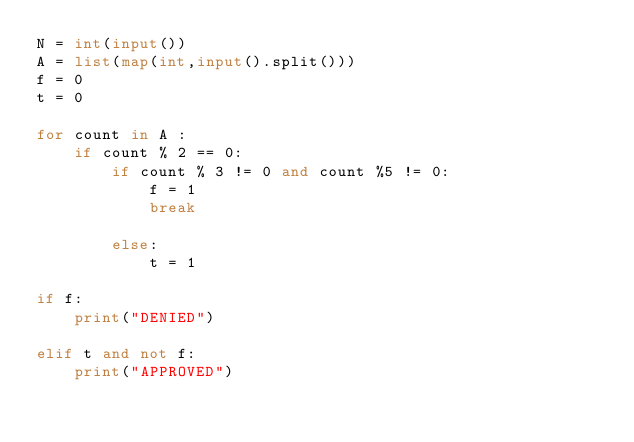Convert code to text. <code><loc_0><loc_0><loc_500><loc_500><_Python_>N = int(input())
A = list(map(int,input().split()))
f = 0
t = 0

for count in A :
    if count % 2 == 0:
        if count % 3 != 0 and count %5 != 0:
            f = 1
            break

        else:
            t = 1

if f:
    print("DENIED")

elif t and not f:
    print("APPROVED")
</code> 